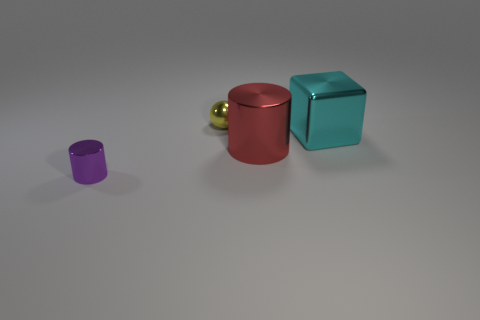Subtract all red cylinders. How many cylinders are left? 1 Add 2 large cyan shiny balls. How many objects exist? 6 Add 1 small brown metal blocks. How many small brown metal blocks exist? 1 Subtract 0 green spheres. How many objects are left? 4 Subtract all balls. How many objects are left? 3 Subtract all blue blocks. Subtract all cyan cylinders. How many blocks are left? 1 Subtract all red metallic objects. Subtract all cylinders. How many objects are left? 1 Add 3 small spheres. How many small spheres are left? 4 